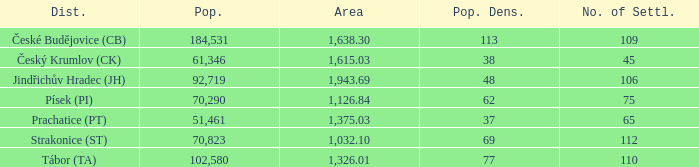What is the population with an area of 1,126.84? 70290.0. 